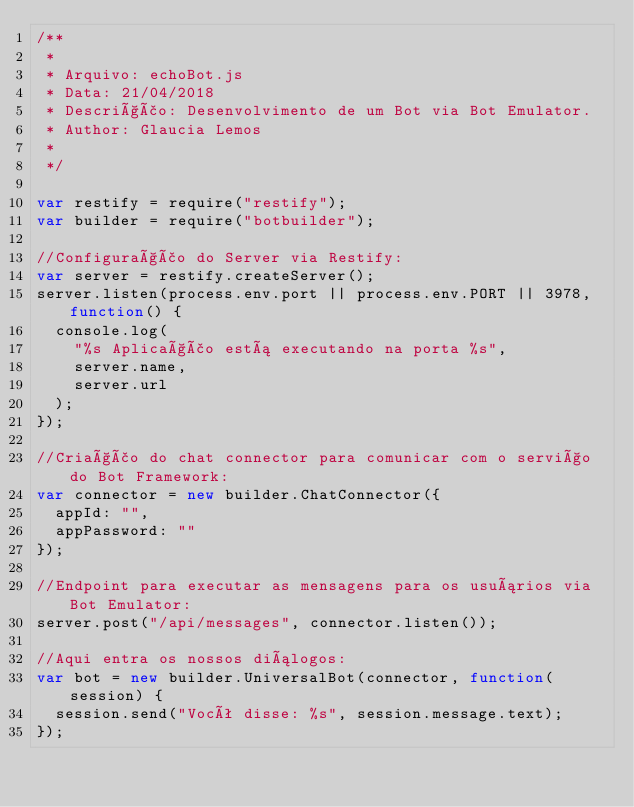<code> <loc_0><loc_0><loc_500><loc_500><_JavaScript_>/**
 * 
 * Arquivo: echoBot.js
 * Data: 21/04/2018
 * Descrição: Desenvolvimento de um Bot via Bot Emulator.
 * Author: Glaucia Lemos
 *
 */

var restify = require("restify");
var builder = require("botbuilder");

//Configuração do Server via Restify:
var server = restify.createServer();
server.listen(process.env.port || process.env.PORT || 3978, function() {
  console.log(
    "%s Aplicação está executando na porta %s",
    server.name,
    server.url
  );
});

//Criação do chat connector para comunicar com o serviço do Bot Framework:
var connector = new builder.ChatConnector({
  appId: "",
  appPassword: ""
});

//Endpoint para executar as mensagens para os usuários via Bot Emulator:
server.post("/api/messages", connector.listen());

//Aqui entra os nossos diálogos:
var bot = new builder.UniversalBot(connector, function(session) {
  session.send("Você disse: %s", session.message.text);
});
</code> 